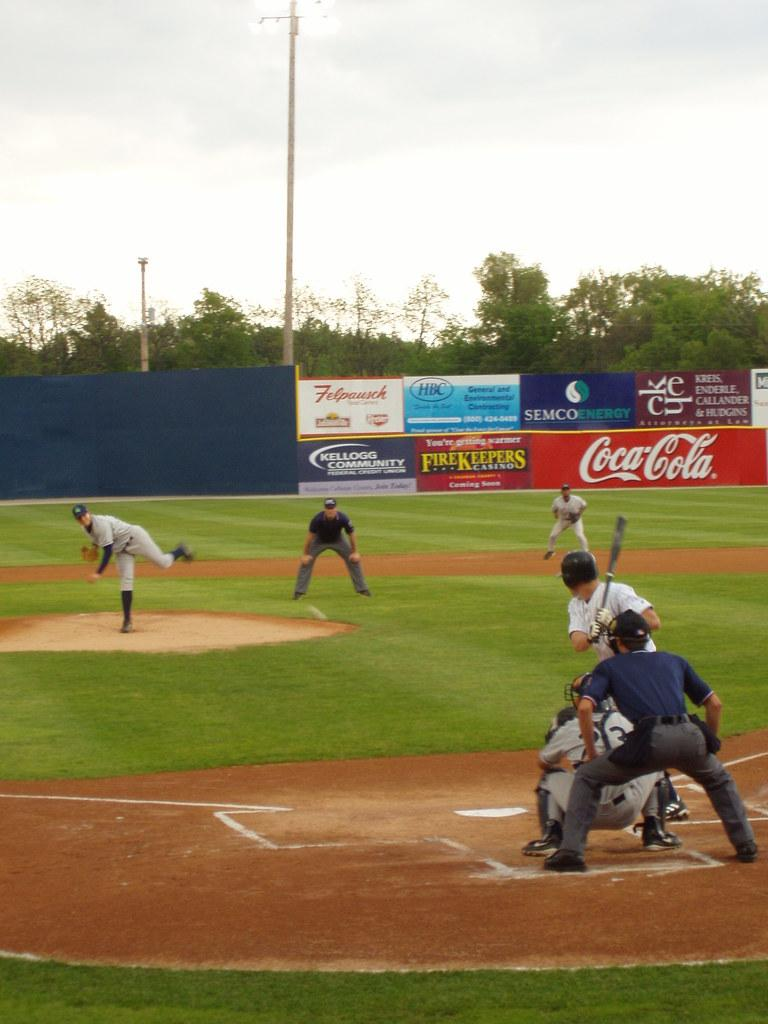<image>
Give a short and clear explanation of the subsequent image. In the packground is a Coca Cola advertisement while the pitcher pitches the ball to the pitcher. 